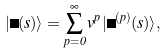Convert formula to latex. <formula><loc_0><loc_0><loc_500><loc_500>| \Psi ( s ) \rangle = \sum _ { p = 0 } ^ { \infty } v ^ { p } | \Psi ^ { ( p ) } ( s ) \rangle ,</formula> 